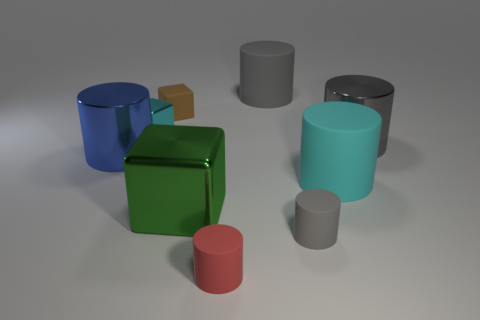There is a metallic cylinder left of the gray cylinder behind the brown thing; what is its color?
Your answer should be very brief. Blue. What size is the metallic cube that is in front of the large cyan object?
Keep it short and to the point. Large. Is there a large gray thing that has the same material as the red thing?
Your answer should be very brief. Yes. How many small rubber things have the same shape as the large blue object?
Offer a very short reply. 2. There is a gray rubber thing that is behind the gray thing that is in front of the big gray object that is in front of the tiny metallic block; what shape is it?
Provide a short and direct response. Cylinder. What is the material of the thing that is both behind the small metal thing and right of the small brown object?
Give a very brief answer. Rubber. Does the gray thing behind the gray metal cylinder have the same size as the tiny red matte cylinder?
Give a very brief answer. No. Are there any other things that are the same size as the cyan shiny block?
Keep it short and to the point. Yes. Is the number of shiny cubes that are to the right of the large gray matte object greater than the number of tiny cyan things behind the brown block?
Your response must be concise. No. What is the color of the large cylinder that is left of the cyan object behind the large shiny cylinder that is on the right side of the small red object?
Your response must be concise. Blue. 